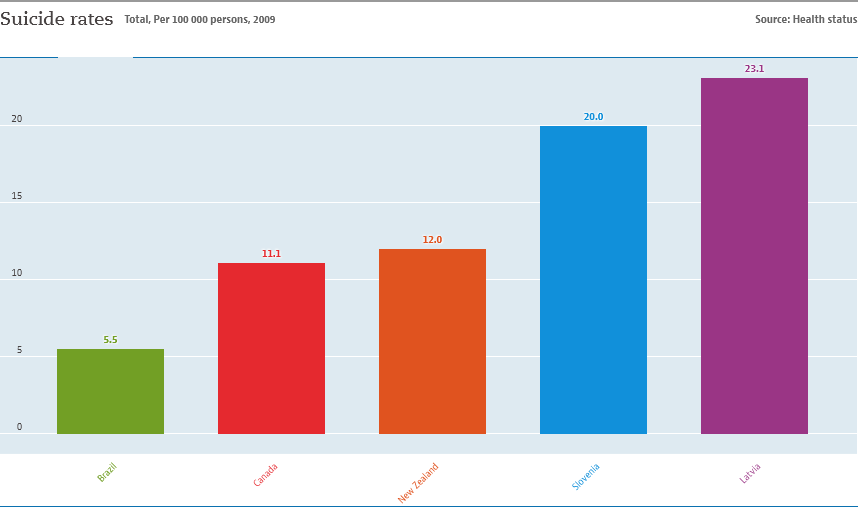Point out several critical features in this image. The average suicide rate across the three smallest countries is 1.238 and can be calculated by adding the three smallest suicide rates and dividing the result by the maximum suicide rate across all the countries. The ratio of the purple bar to the green bar is 4.2. 